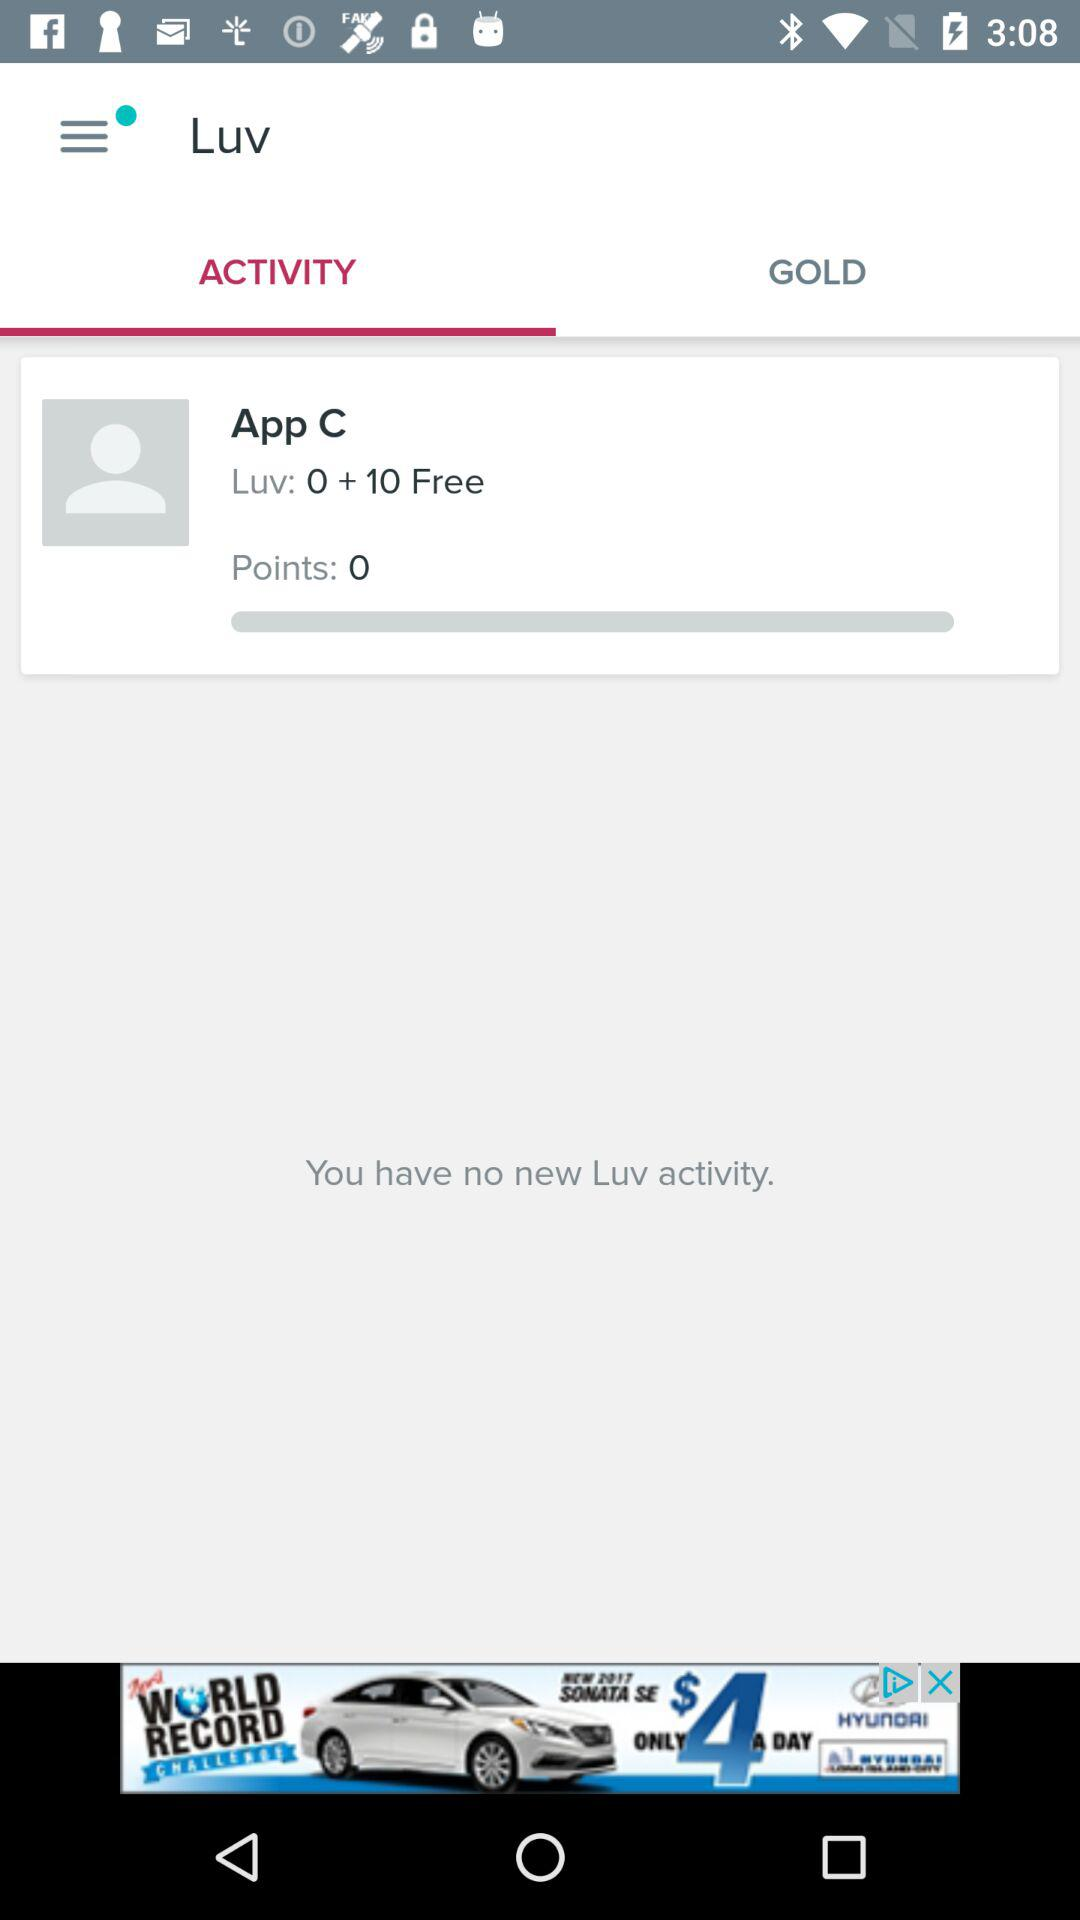Is there any new Luv activity apart from App C? There is no new Luv activity apart from App C. 